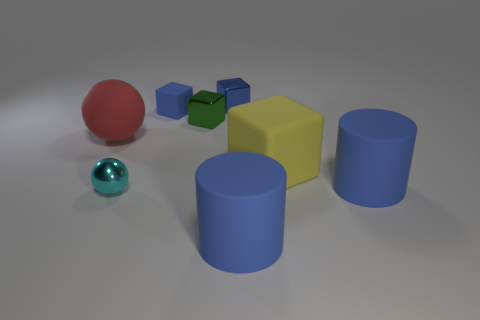How does the lighting affect the appearance of the objects? The lighting in the image is soft and diffuse, casting gentle shadows that help define the three-dimensional forms of each object. It enhances the visual texture of the objects, particularly highlighting the difference between the matte and shiny surfaces. The lighting direction also seems to be from a high angle, as indicated by the position of the shadows. 